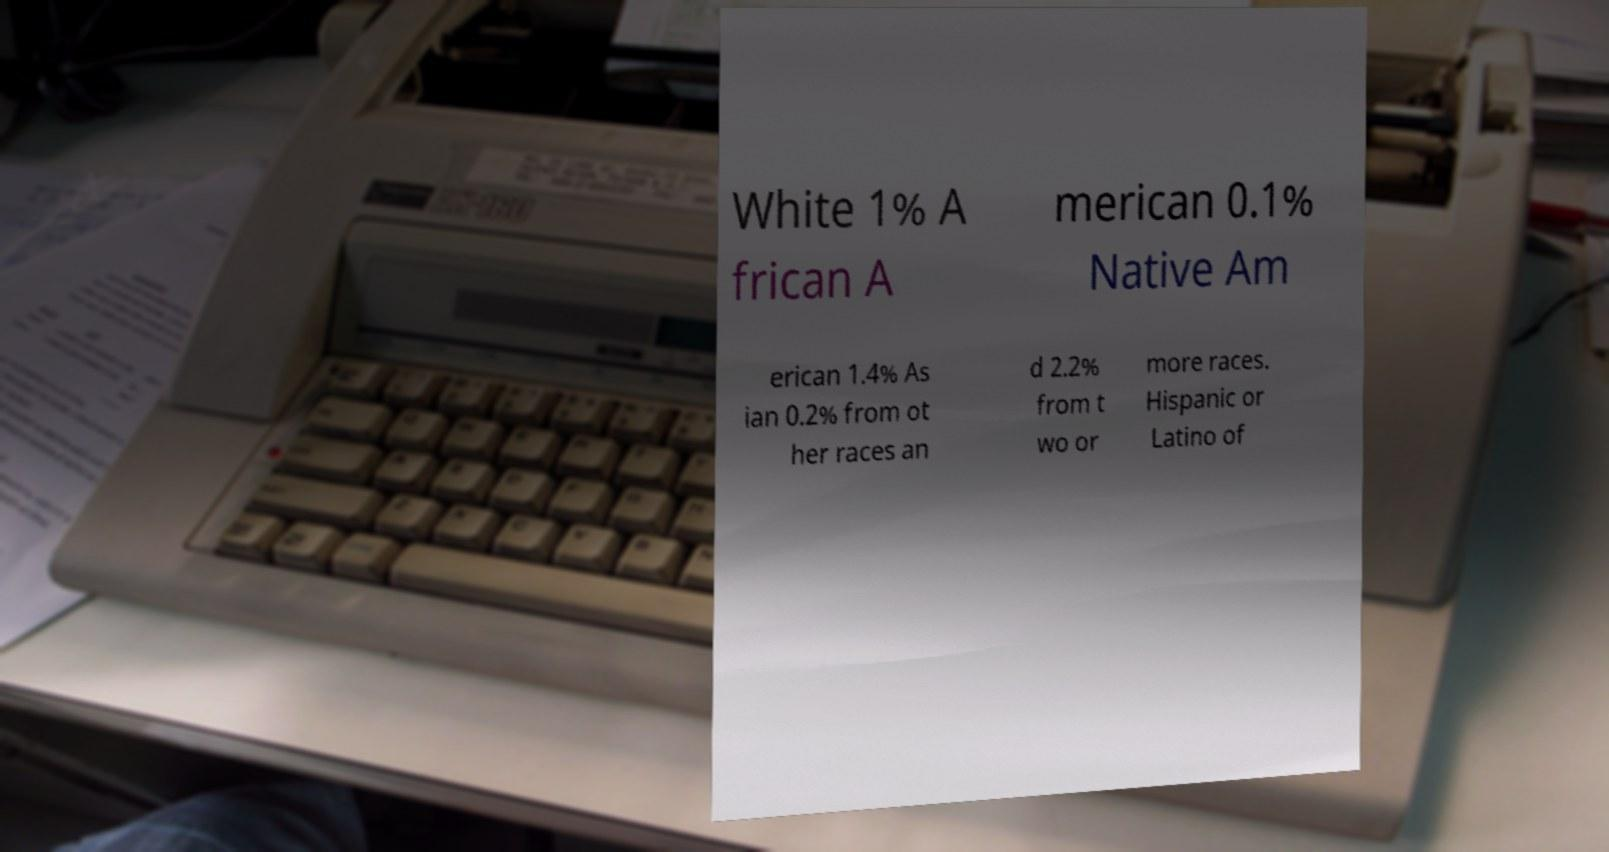Can you accurately transcribe the text from the provided image for me? White 1% A frican A merican 0.1% Native Am erican 1.4% As ian 0.2% from ot her races an d 2.2% from t wo or more races. Hispanic or Latino of 